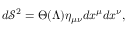<formula> <loc_0><loc_0><loc_500><loc_500>d \mathcal { S } ^ { 2 } = \Theta ( \Lambda ) \eta _ { \mu \nu } d x ^ { \mu } d x ^ { \nu } ,</formula> 